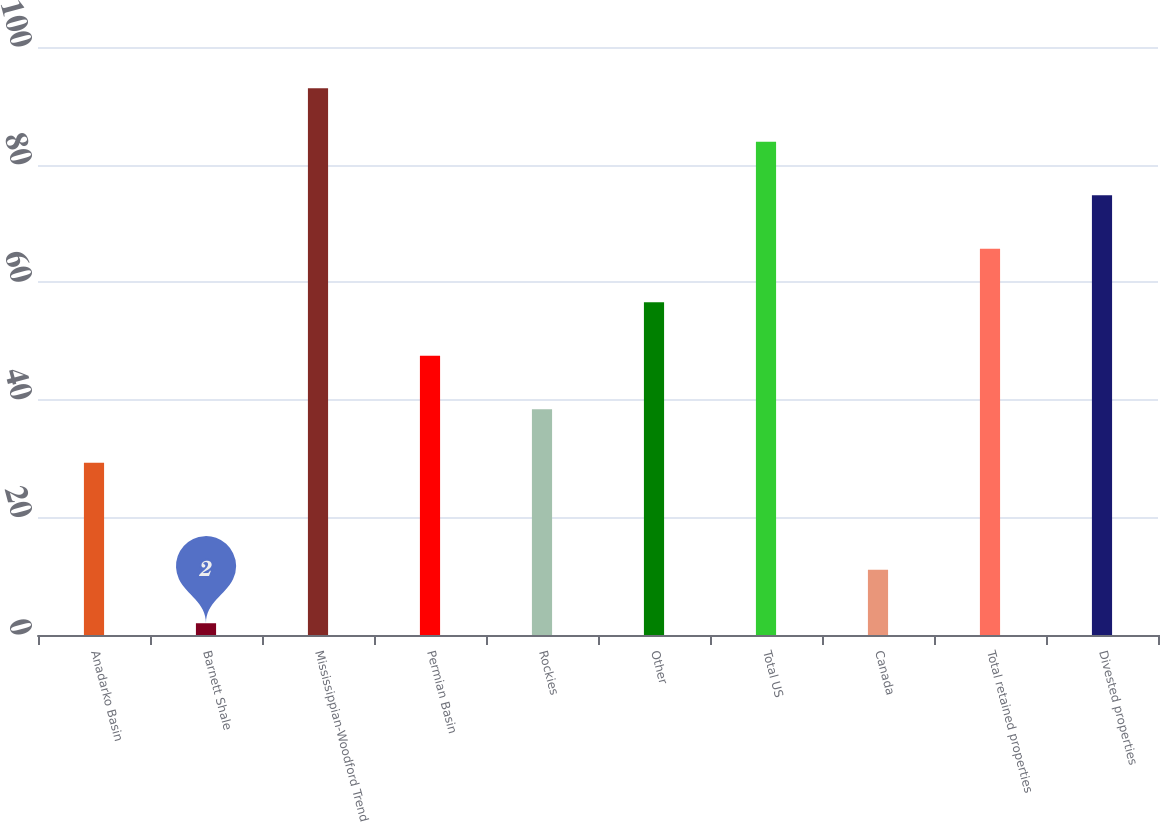<chart> <loc_0><loc_0><loc_500><loc_500><bar_chart><fcel>Anadarko Basin<fcel>Barnett Shale<fcel>Mississippian-Woodford Trend<fcel>Permian Basin<fcel>Rockies<fcel>Other<fcel>Total US<fcel>Canada<fcel>Total retained properties<fcel>Divested properties<nl><fcel>29.3<fcel>2<fcel>93<fcel>47.5<fcel>38.4<fcel>56.6<fcel>83.9<fcel>11.1<fcel>65.7<fcel>74.8<nl></chart> 